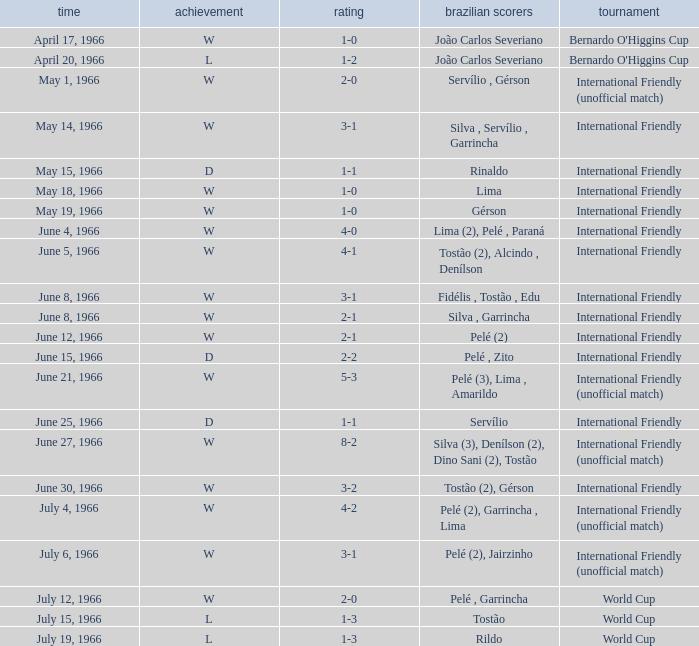What is the result when the score is 4-0? W. 